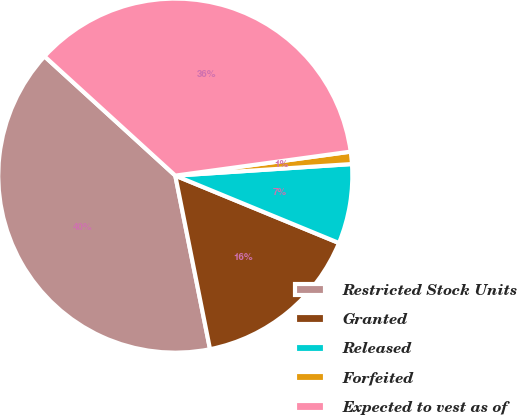Convert chart to OTSL. <chart><loc_0><loc_0><loc_500><loc_500><pie_chart><fcel>Restricted Stock Units<fcel>Granted<fcel>Released<fcel>Forfeited<fcel>Expected to vest as of<nl><fcel>39.91%<fcel>15.64%<fcel>7.26%<fcel>1.12%<fcel>36.07%<nl></chart> 